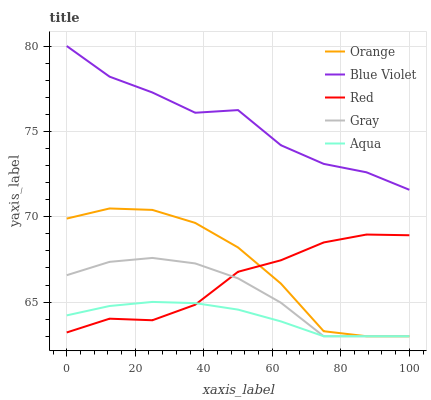Does Aqua have the minimum area under the curve?
Answer yes or no. Yes. Does Blue Violet have the maximum area under the curve?
Answer yes or no. Yes. Does Gray have the minimum area under the curve?
Answer yes or no. No. Does Gray have the maximum area under the curve?
Answer yes or no. No. Is Aqua the smoothest?
Answer yes or no. Yes. Is Blue Violet the roughest?
Answer yes or no. Yes. Is Gray the smoothest?
Answer yes or no. No. Is Gray the roughest?
Answer yes or no. No. Does Orange have the lowest value?
Answer yes or no. Yes. Does Red have the lowest value?
Answer yes or no. No. Does Blue Violet have the highest value?
Answer yes or no. Yes. Does Gray have the highest value?
Answer yes or no. No. Is Aqua less than Blue Violet?
Answer yes or no. Yes. Is Blue Violet greater than Gray?
Answer yes or no. Yes. Does Gray intersect Orange?
Answer yes or no. Yes. Is Gray less than Orange?
Answer yes or no. No. Is Gray greater than Orange?
Answer yes or no. No. Does Aqua intersect Blue Violet?
Answer yes or no. No. 